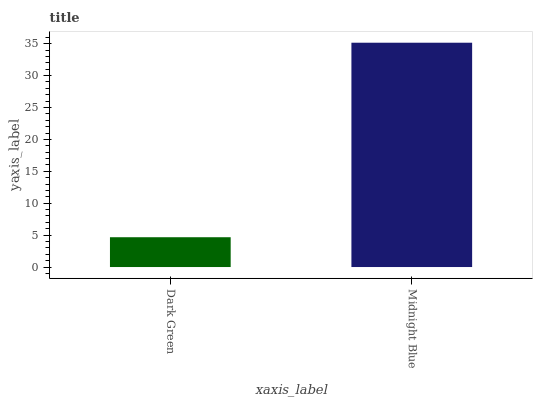Is Midnight Blue the minimum?
Answer yes or no. No. Is Midnight Blue greater than Dark Green?
Answer yes or no. Yes. Is Dark Green less than Midnight Blue?
Answer yes or no. Yes. Is Dark Green greater than Midnight Blue?
Answer yes or no. No. Is Midnight Blue less than Dark Green?
Answer yes or no. No. Is Midnight Blue the high median?
Answer yes or no. Yes. Is Dark Green the low median?
Answer yes or no. Yes. Is Dark Green the high median?
Answer yes or no. No. Is Midnight Blue the low median?
Answer yes or no. No. 